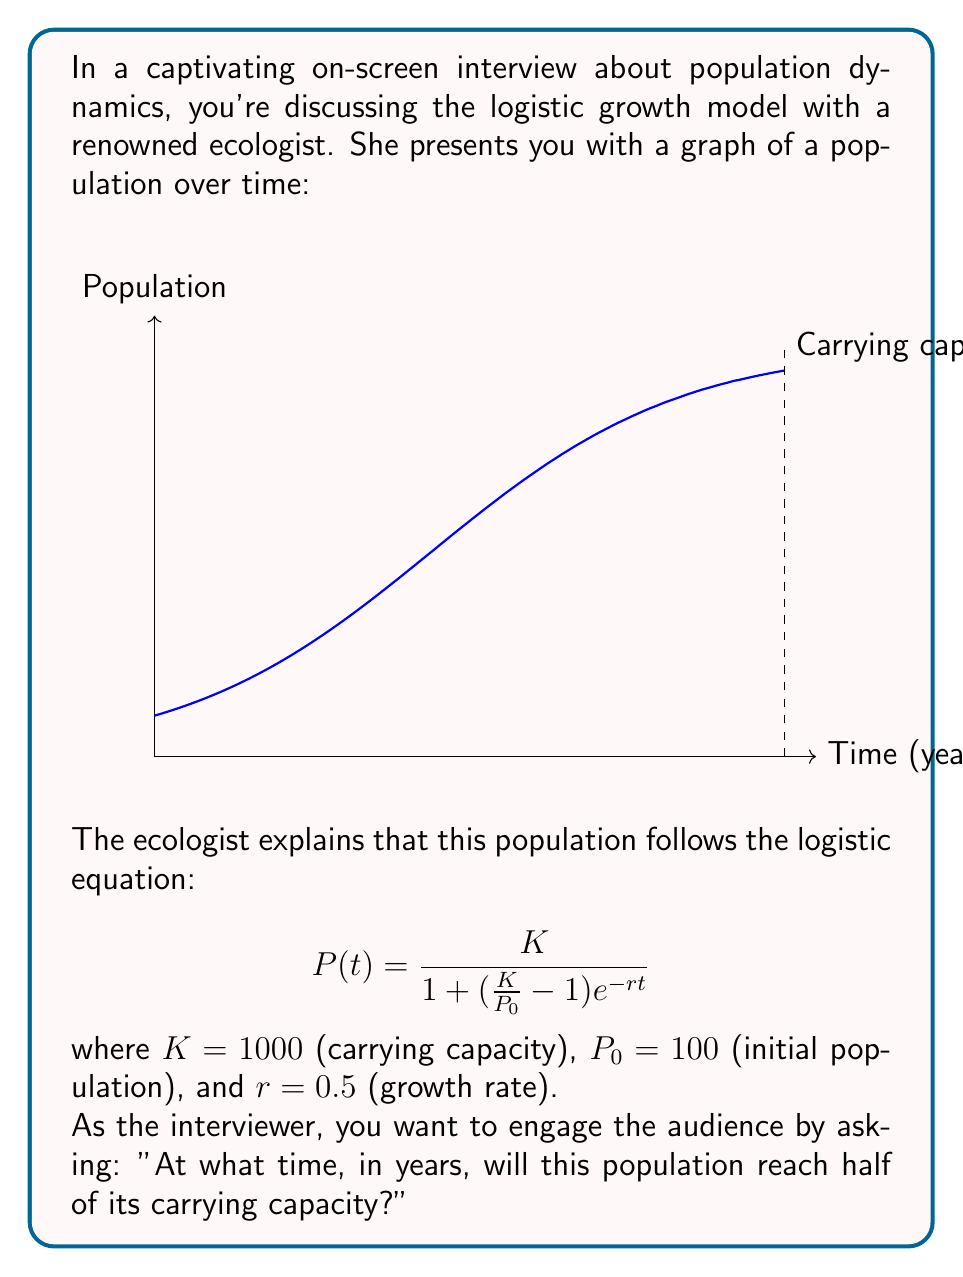Give your solution to this math problem. To solve this problem, we'll follow these steps:

1) We need to find $t$ when $P(t) = K/2 = 500$.

2) Substitute the known values into the logistic equation:

   $$500 = \frac{1000}{1 + (\frac{1000}{100} - 1)e^{-0.5t}}$$

3) Simplify:

   $$500 = \frac{1000}{1 + 9e^{-0.5t}}$$

4) Multiply both sides by $(1 + 9e^{-0.5t})$:

   $$500(1 + 9e^{-0.5t}) = 1000$$

5) Expand:

   $$500 + 4500e^{-0.5t} = 1000$$

6) Subtract 500 from both sides:

   $$4500e^{-0.5t} = 500$$

7) Divide both sides by 4500:

   $$e^{-0.5t} = \frac{1}{9}$$

8) Take the natural log of both sides:

   $$-0.5t = \ln(\frac{1}{9}) = -\ln(9)$$

9) Divide both sides by -0.5:

   $$t = \frac{\ln(9)}{0.5} = 2\ln(9) \approx 4.39$$

Therefore, the population will reach half of its carrying capacity after approximately 4.39 years.
Answer: $2\ln(9) \approx 4.39$ years 